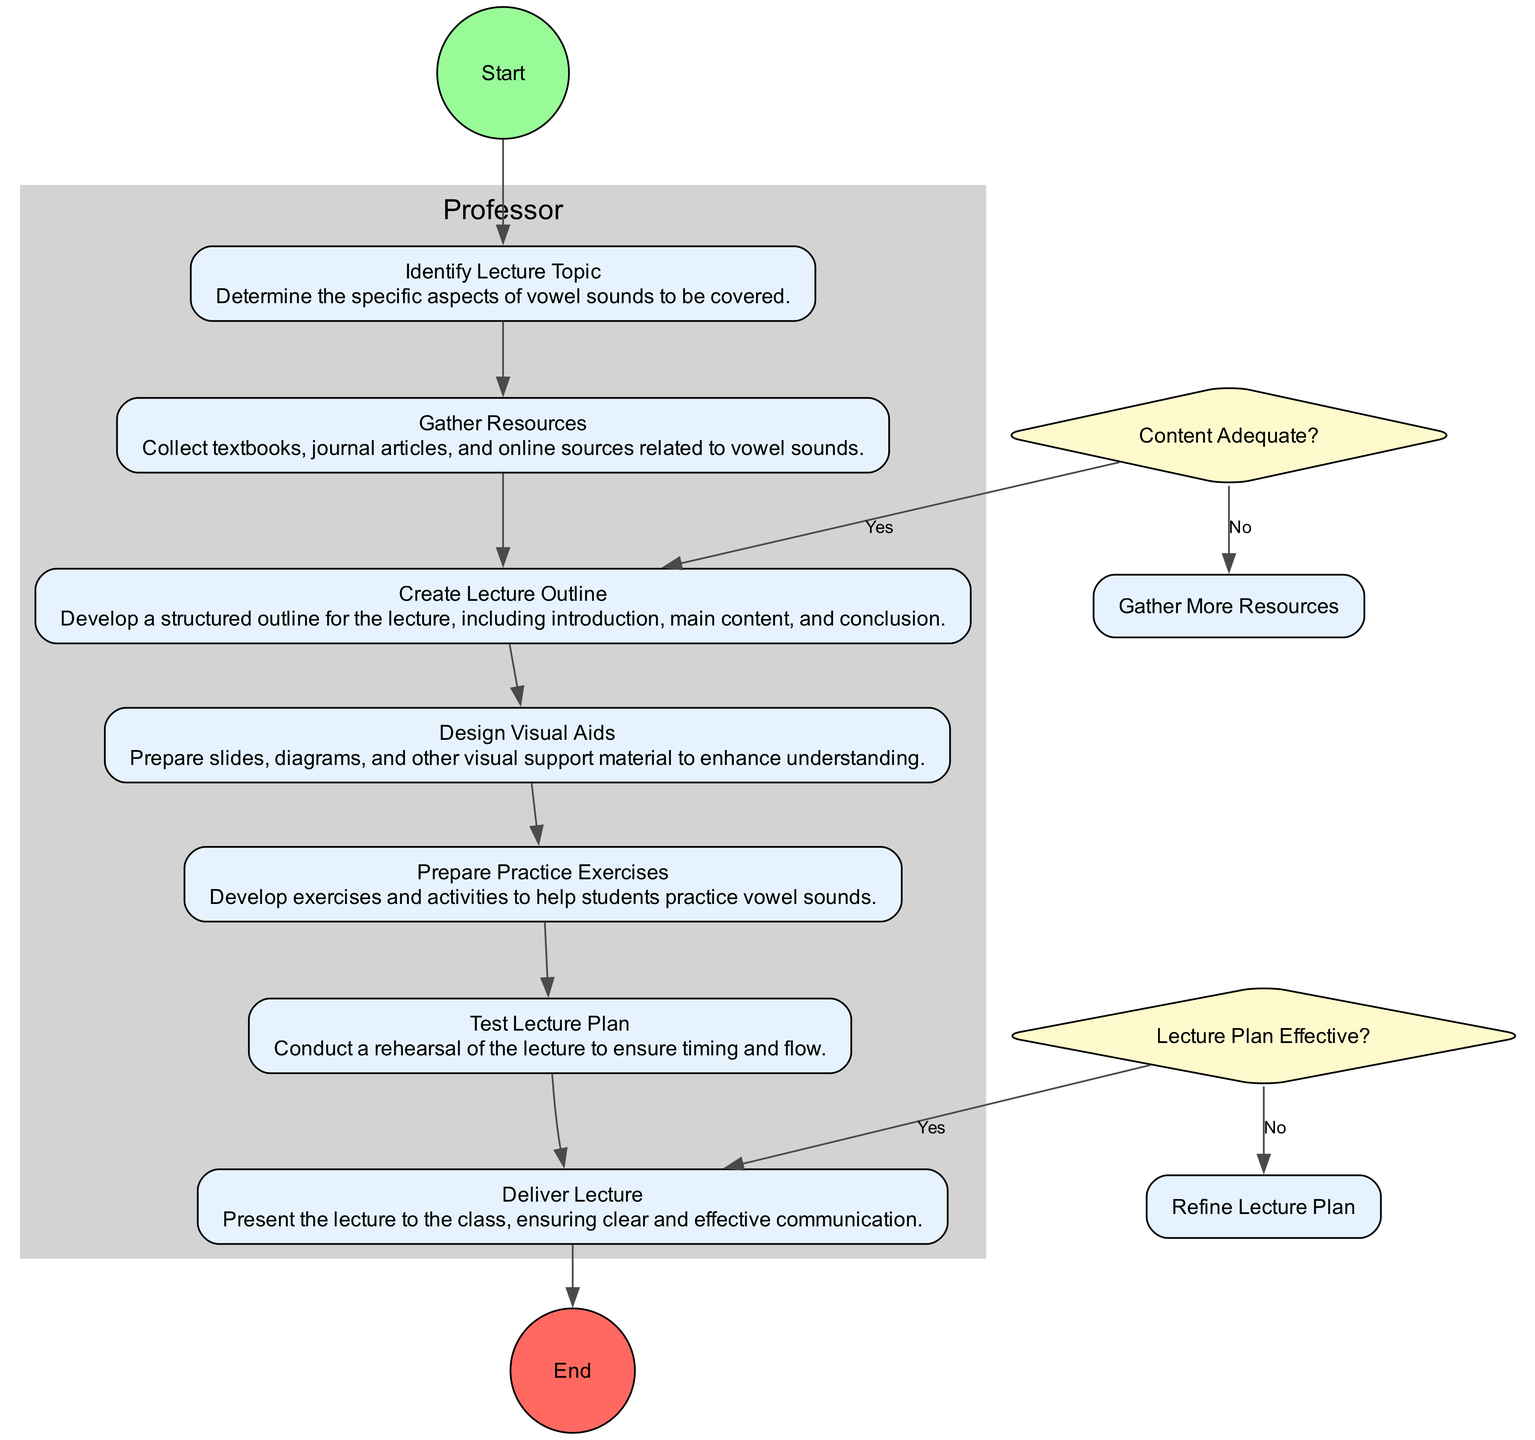What is the starting activity in the diagram? The starting activity is indicated at the top of the diagram as "Identify Lecture Topic," which is the first action in the workflow.
Answer: Identify Lecture Topic How many activities are there in total? Counting all activities listed in the diagram, there are seven distinct activities from "Identify Lecture Topic" to "Deliver Lecture."
Answer: 7 What happens if the gathered content is not sufficient? If the content is not sufficient, the flow dictates that it will lead to the activity "Gather More Resources" after the decision node "Content Adequate?"
Answer: Gather More Resources Which activity follows the "Test Lecture Plan"? According to the activities flow, "Test Lecture Plan" leads directly to "Deliver Lecture," indicating the next step in the process.
Answer: Deliver Lecture What type of decision does "Lecture Plan Effective?" represent? This decision type is represented as a diamond shape in the diagram, which typically indicates a branching point based on a yes or no evaluation of the lecture plan's effectiveness.
Answer: Diamond If the gathered resources are adequate, what is the next step? If the gathered resources are confirmed as adequate, the next step according to the workflow will be "Create Lecture Outline," which structures the content for the lecture.
Answer: Create Lecture Outline What activity involves designing materials for the lecture? The activity specifically involving the design of materials is "Design Visual Aids," where visual support material like slides and diagrams are prepared.
Answer: Design Visual Aids What is the final activity in this workflow? The final activity in the workflow is "Deliver Lecture," which is the culmination of all preceding activities aimed at presenting the lecture.
Answer: Deliver Lecture 